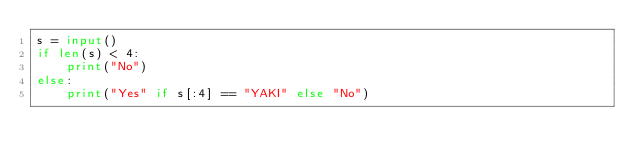<code> <loc_0><loc_0><loc_500><loc_500><_Python_>s = input()
if len(s) < 4:
    print("No")
else:
    print("Yes" if s[:4] == "YAKI" else "No")</code> 